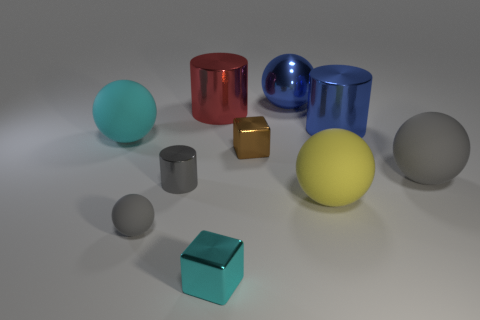How many large things are either brown metal blocks or spheres? Upon examining the image, there are a total of three large spheres and no large brown metal blocks, making the revised count three large items fitting the description. 